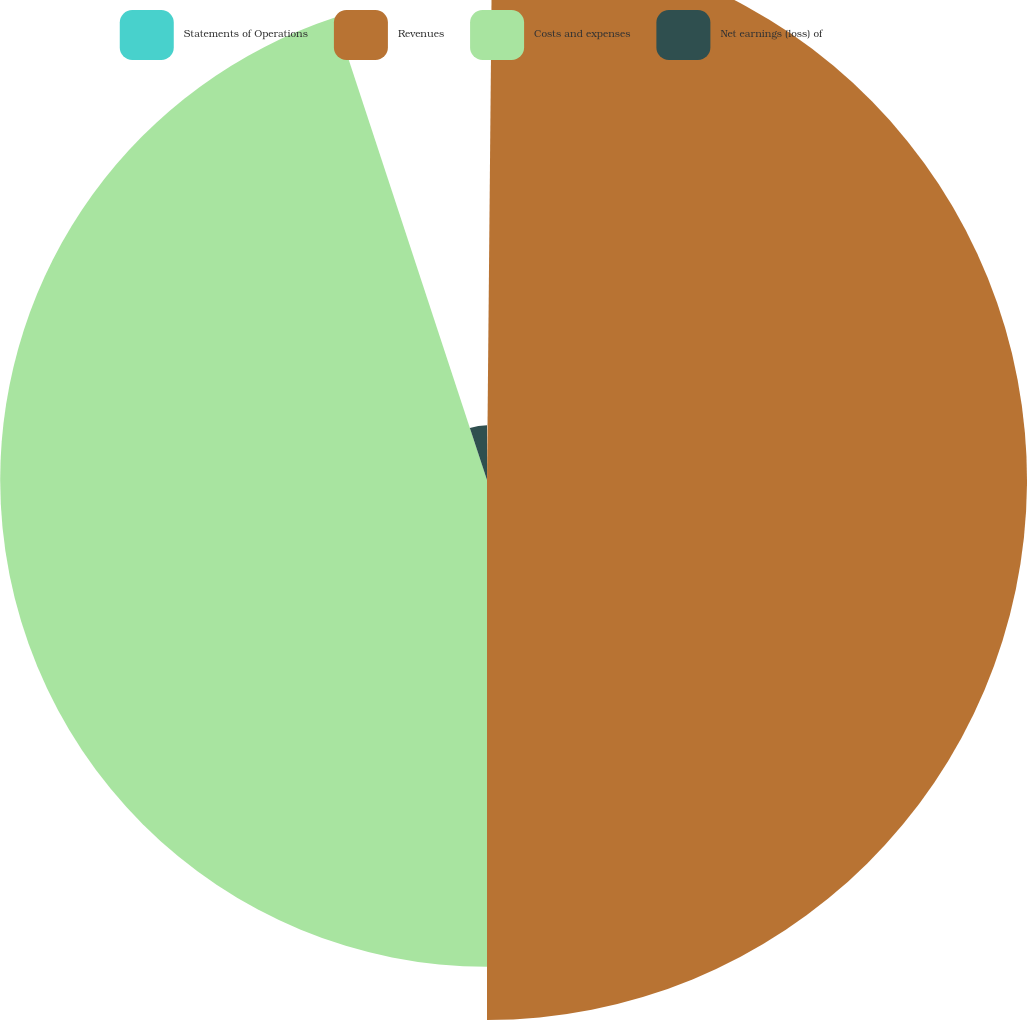Convert chart to OTSL. <chart><loc_0><loc_0><loc_500><loc_500><pie_chart><fcel>Statements of Operations<fcel>Revenues<fcel>Costs and expenses<fcel>Net earnings (loss) of<nl><fcel>0.15%<fcel>49.85%<fcel>44.94%<fcel>5.06%<nl></chart> 